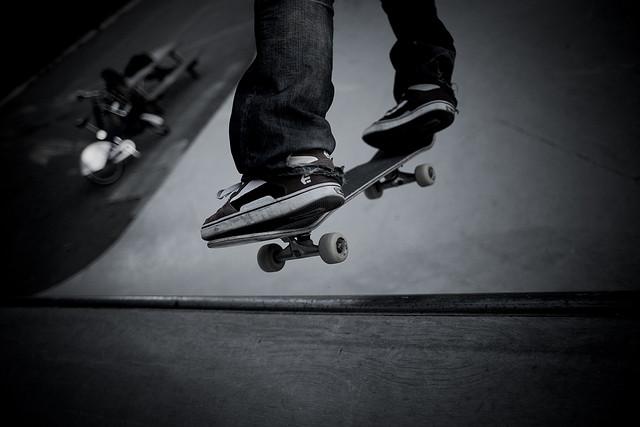What is the color of the skateboard?
Short answer required. Black. Is the skateboard flying?
Quick response, please. Yes. What color is the skateboard?
Write a very short answer. Black. Is the skater wearing a belt?
Quick response, please. No. Is the skateboarder wearing shorts?
Quick response, please. No. What is the brand name of his shoes?
Be succinct. Etnies. 